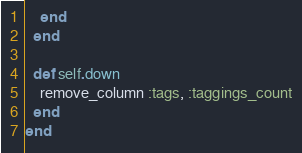<code> <loc_0><loc_0><loc_500><loc_500><_Ruby_>    end
  end

  def self.down
    remove_column :tags, :taggings_count
  end
end
</code> 